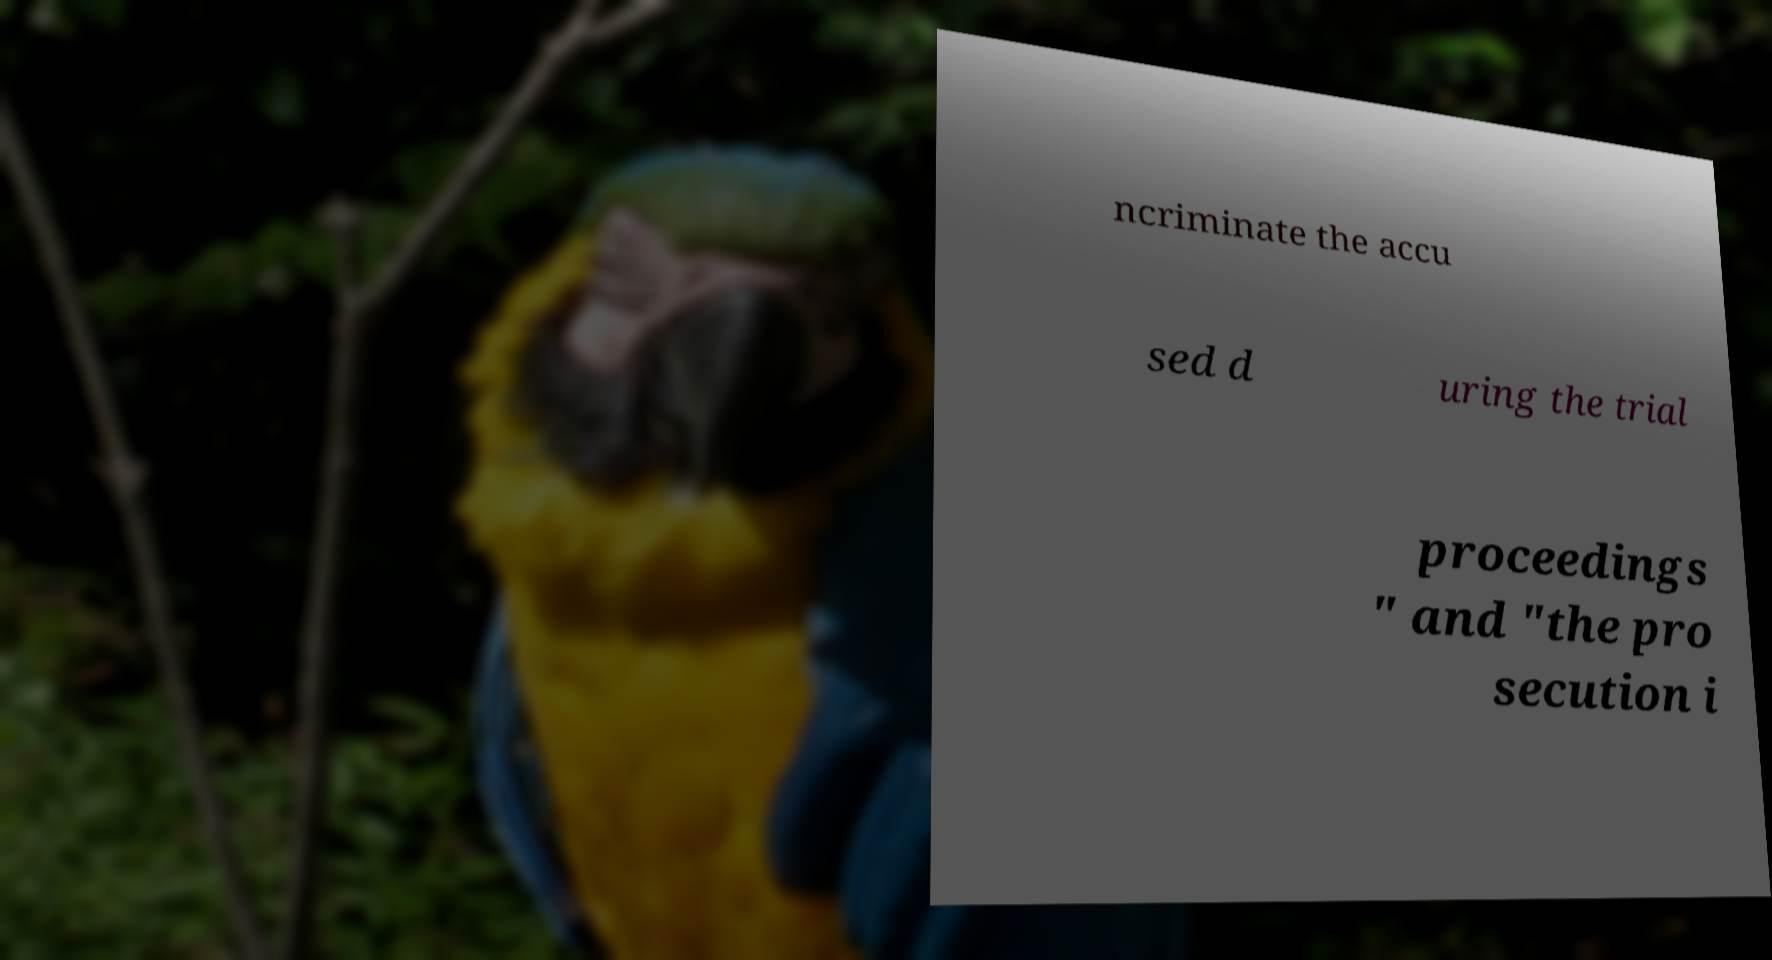What messages or text are displayed in this image? I need them in a readable, typed format. ncriminate the accu sed d uring the trial proceedings " and "the pro secution i 